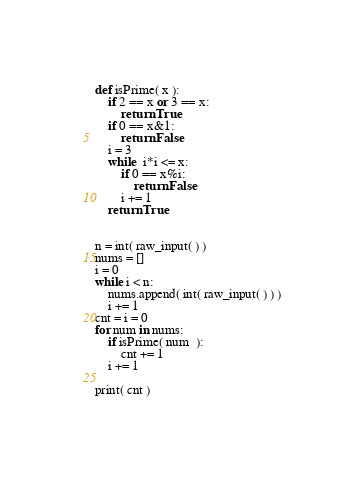Convert code to text. <code><loc_0><loc_0><loc_500><loc_500><_Python_>def isPrime( x ):
	if 2 == x or 3 == x:
		return True
	if 0 == x&1:
		return False
	i = 3 
	while  i*i <= x:
		if 0 == x%i:
			return False
		i += 1
	return True


n = int( raw_input( ) )
nums = []
i = 0
while i < n:
	nums.append( int( raw_input( ) ) )
	i += 1
cnt = i = 0
for num in nums:
	if isPrime( num  ):
		cnt += 1
	i += 1

print( cnt )</code> 